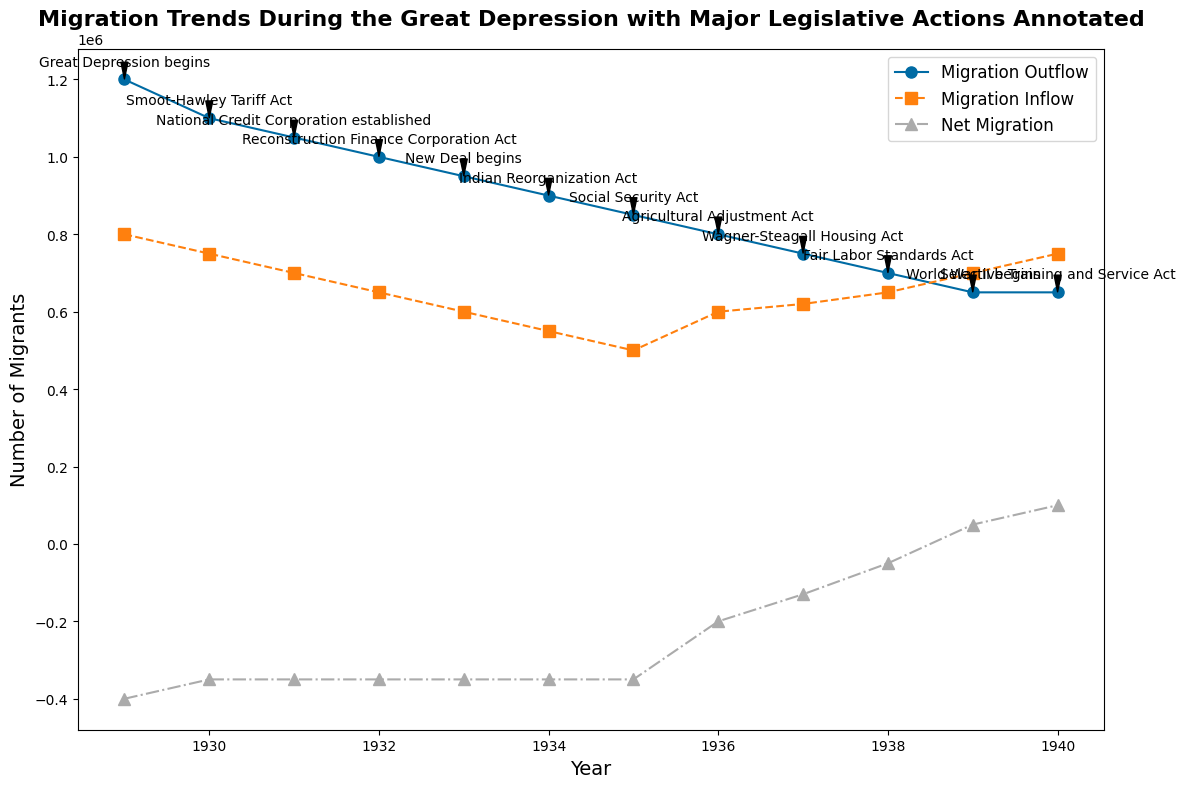What year had the highest Migration Outflow? By looking at the plotted Migration Outflow line, the highest point is in the year 1929.
Answer: 1929 Which major legislative action is associated with the year when Net Migration turns positive? The first year when the Net Migration is above zero is 1939. Looking at the annotations, this corresponds to "World War II begins".
Answer: "World War II begins" What is the difference in Migration Inflow between the years with the Smoot-Hawley Tariff Act and the Fair Labor Standards Act? In 1930, during the Smoot-Hawley Tariff Act, Migration Inflow was 750,000. In 1938, during the Fair Labor Standards Act, Migration Inflow was 650,000. The difference is 750,000 - 650,000 = 100,000.
Answer: 100,000 Between the years 1930 and 1935 which had the smallest Net Migration? By comparing the Net Migration values for each year from 1930 to 1935, all are -350,000, so they are the same.
Answer: -350,000 In what year did the New Deal begin, and what was the migration trend (inflow and outflow) in that year? The New Deal began in 1933. Migration Outflow was 950,000 and Migration Inflow was 600,000 in that year.
Answer: 1933, Outflow: 950,000, Inflow: 600,000 Compare the Migration Inflow and Outflow in 1940. Which one is higher, and by how much? In 1940, Migration Outflow was 650,000 and Migration Inflow was 750,000. Inflow is higher by 750,000 - 650,000 = 100,000.
Answer: Inflow is higher by 100,000 How does Migration Outflow change from 1934 to 1937? Migration Outflow decreases year by year from 1934 (900,000) to 1937 (750,000).
Answer: It decreases consistently Which legislative action corresponds to the largest single-year decrease in Migration Outflow, and what is the change amount? The largest single-year decrease in Migration Outflow happened from 1929 (1,200,000) to 1930 (1,100,000). 1,200,000 - 1,100,000 = 100,000, corresponding to the "Smoot-Hawley Tariff Act".
Answer: "Smoot-Hawley Tariff Act", 100,000 